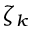<formula> <loc_0><loc_0><loc_500><loc_500>\zeta _ { k }</formula> 